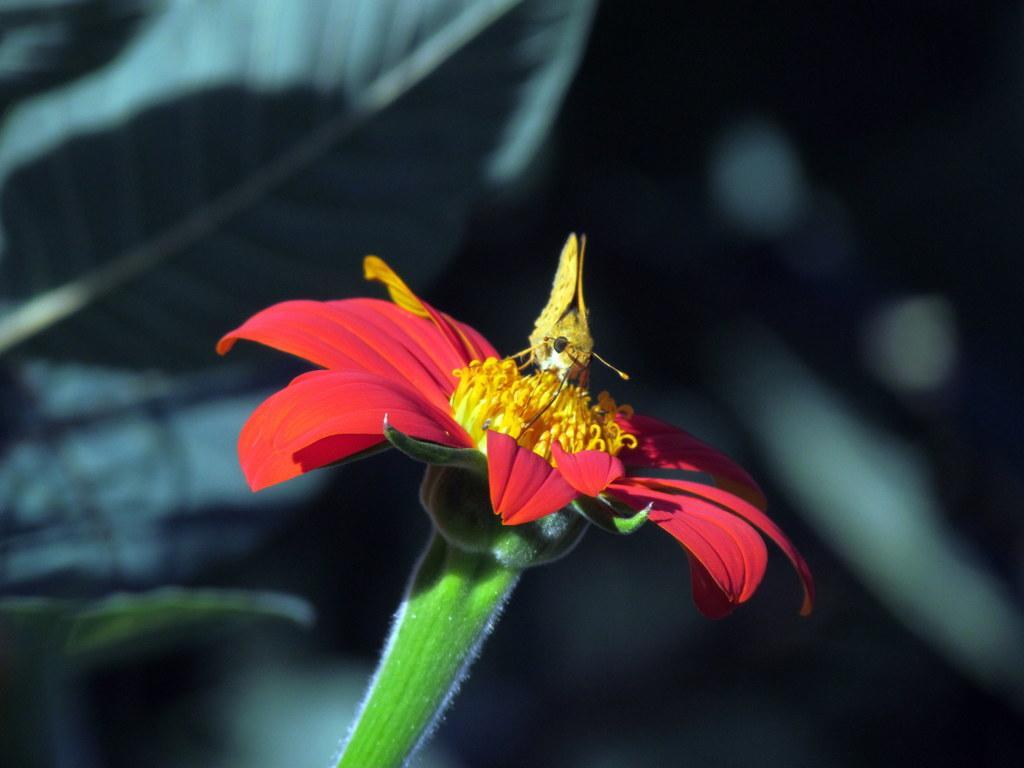Please provide a concise description of this image. There is a red color flower. Which is having yellow color filaments. On the filaments, there is an insect. And the background is blurred. 